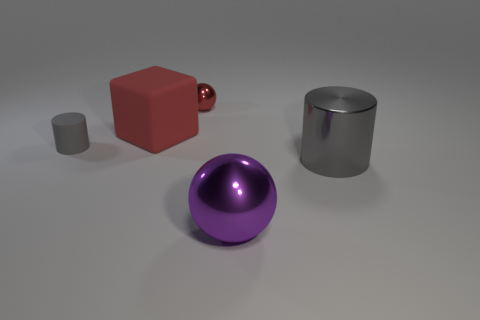Add 2 small gray objects. How many objects exist? 7 Subtract all balls. How many objects are left? 3 Subtract all big gray rubber cylinders. Subtract all purple balls. How many objects are left? 4 Add 2 large purple spheres. How many large purple spheres are left? 3 Add 1 big blue metal cubes. How many big blue metal cubes exist? 1 Subtract 0 green spheres. How many objects are left? 5 